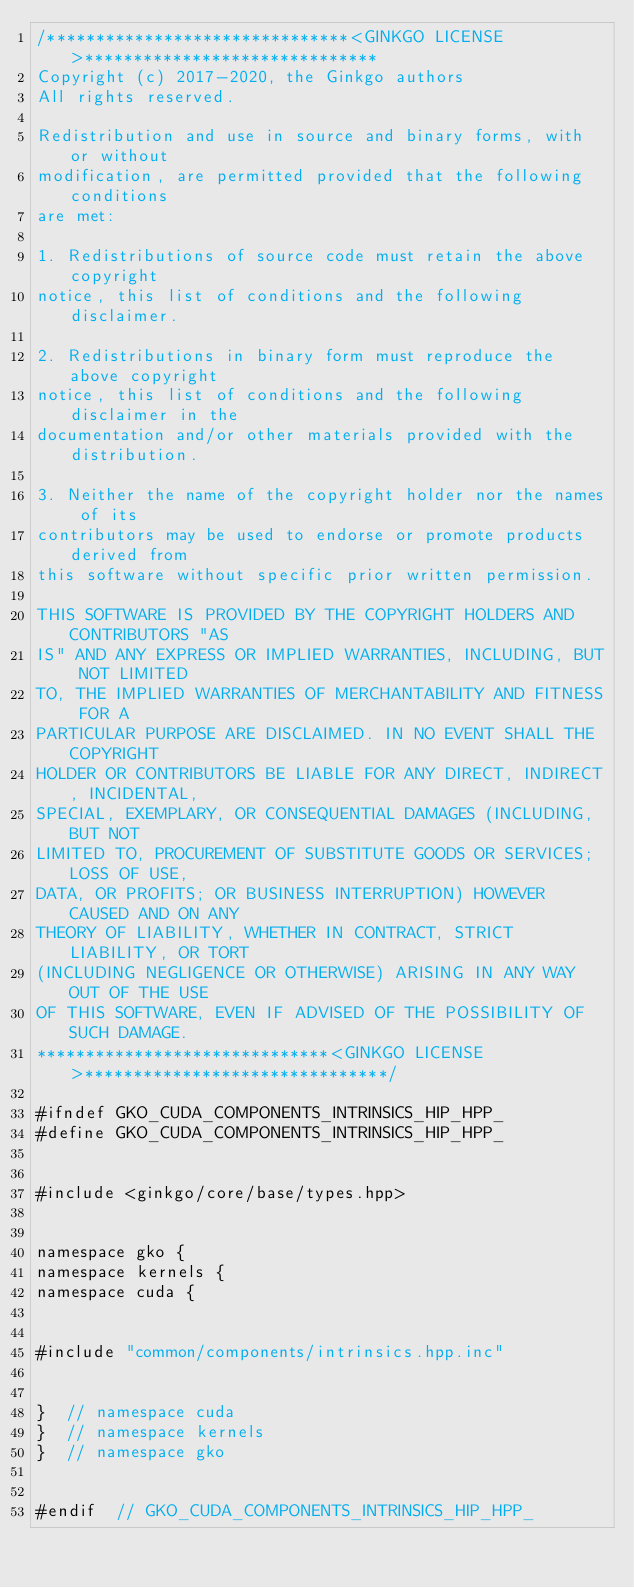Convert code to text. <code><loc_0><loc_0><loc_500><loc_500><_Cuda_>/*******************************<GINKGO LICENSE>******************************
Copyright (c) 2017-2020, the Ginkgo authors
All rights reserved.

Redistribution and use in source and binary forms, with or without
modification, are permitted provided that the following conditions
are met:

1. Redistributions of source code must retain the above copyright
notice, this list of conditions and the following disclaimer.

2. Redistributions in binary form must reproduce the above copyright
notice, this list of conditions and the following disclaimer in the
documentation and/or other materials provided with the distribution.

3. Neither the name of the copyright holder nor the names of its
contributors may be used to endorse or promote products derived from
this software without specific prior written permission.

THIS SOFTWARE IS PROVIDED BY THE COPYRIGHT HOLDERS AND CONTRIBUTORS "AS
IS" AND ANY EXPRESS OR IMPLIED WARRANTIES, INCLUDING, BUT NOT LIMITED
TO, THE IMPLIED WARRANTIES OF MERCHANTABILITY AND FITNESS FOR A
PARTICULAR PURPOSE ARE DISCLAIMED. IN NO EVENT SHALL THE COPYRIGHT
HOLDER OR CONTRIBUTORS BE LIABLE FOR ANY DIRECT, INDIRECT, INCIDENTAL,
SPECIAL, EXEMPLARY, OR CONSEQUENTIAL DAMAGES (INCLUDING, BUT NOT
LIMITED TO, PROCUREMENT OF SUBSTITUTE GOODS OR SERVICES; LOSS OF USE,
DATA, OR PROFITS; OR BUSINESS INTERRUPTION) HOWEVER CAUSED AND ON ANY
THEORY OF LIABILITY, WHETHER IN CONTRACT, STRICT LIABILITY, OR TORT
(INCLUDING NEGLIGENCE OR OTHERWISE) ARISING IN ANY WAY OUT OF THE USE
OF THIS SOFTWARE, EVEN IF ADVISED OF THE POSSIBILITY OF SUCH DAMAGE.
******************************<GINKGO LICENSE>*******************************/

#ifndef GKO_CUDA_COMPONENTS_INTRINSICS_HIP_HPP_
#define GKO_CUDA_COMPONENTS_INTRINSICS_HIP_HPP_


#include <ginkgo/core/base/types.hpp>


namespace gko {
namespace kernels {
namespace cuda {


#include "common/components/intrinsics.hpp.inc"


}  // namespace cuda
}  // namespace kernels
}  // namespace gko


#endif  // GKO_CUDA_COMPONENTS_INTRINSICS_HIP_HPP_</code> 